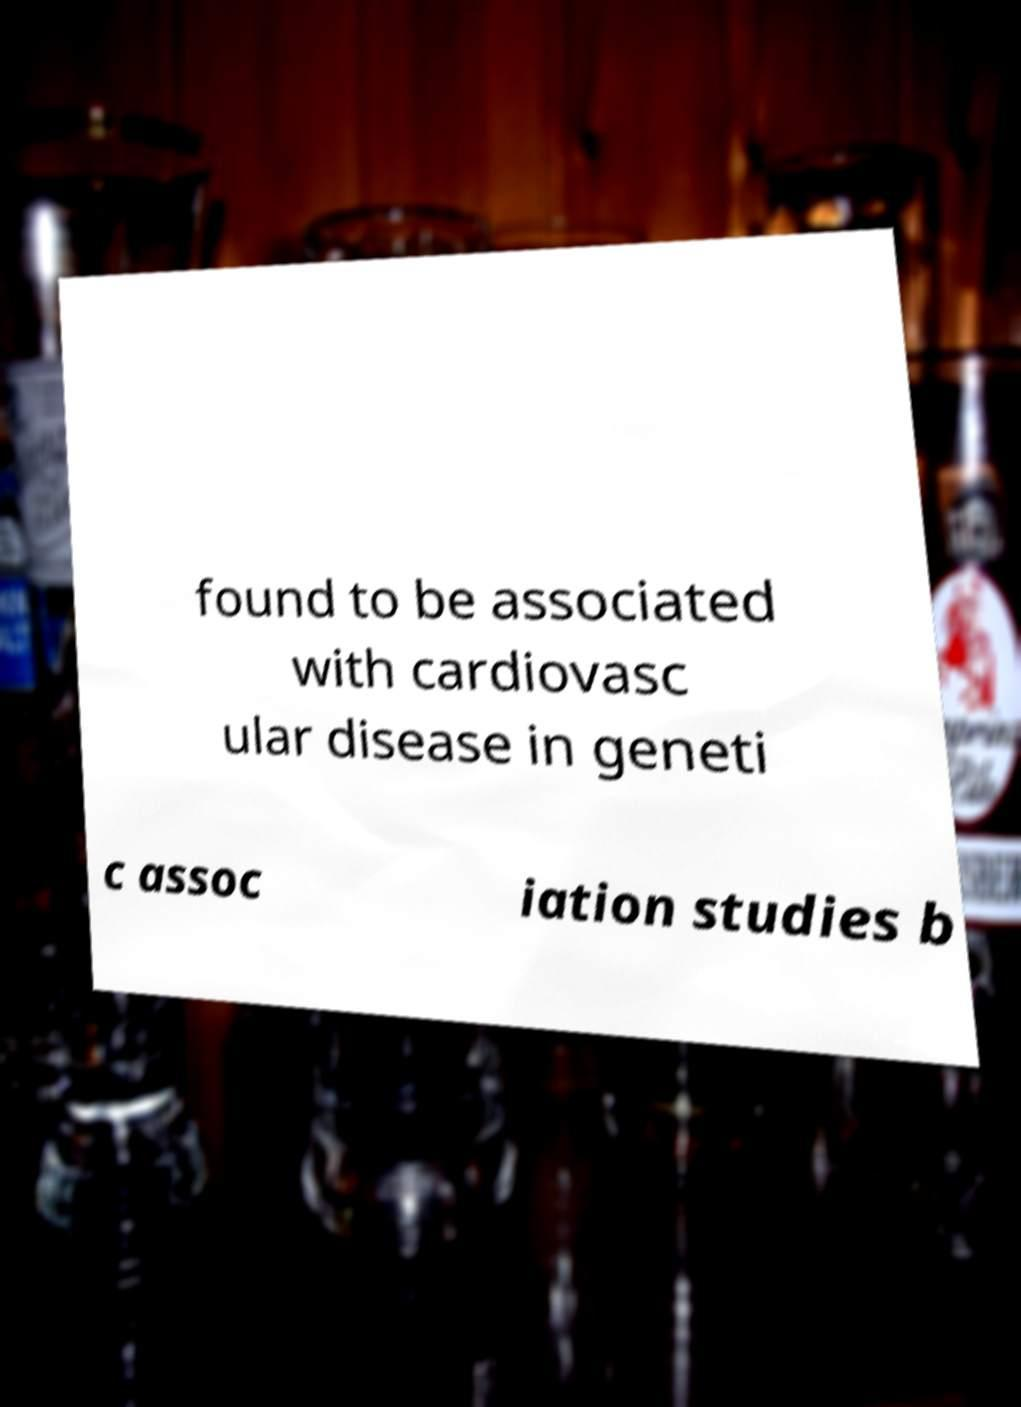There's text embedded in this image that I need extracted. Can you transcribe it verbatim? found to be associated with cardiovasc ular disease in geneti c assoc iation studies b 